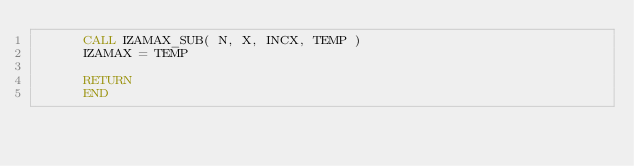<code> <loc_0><loc_0><loc_500><loc_500><_FORTRAN_>      CALL IZAMAX_SUB( N, X, INCX, TEMP )
      IZAMAX = TEMP

      RETURN
      END
</code> 